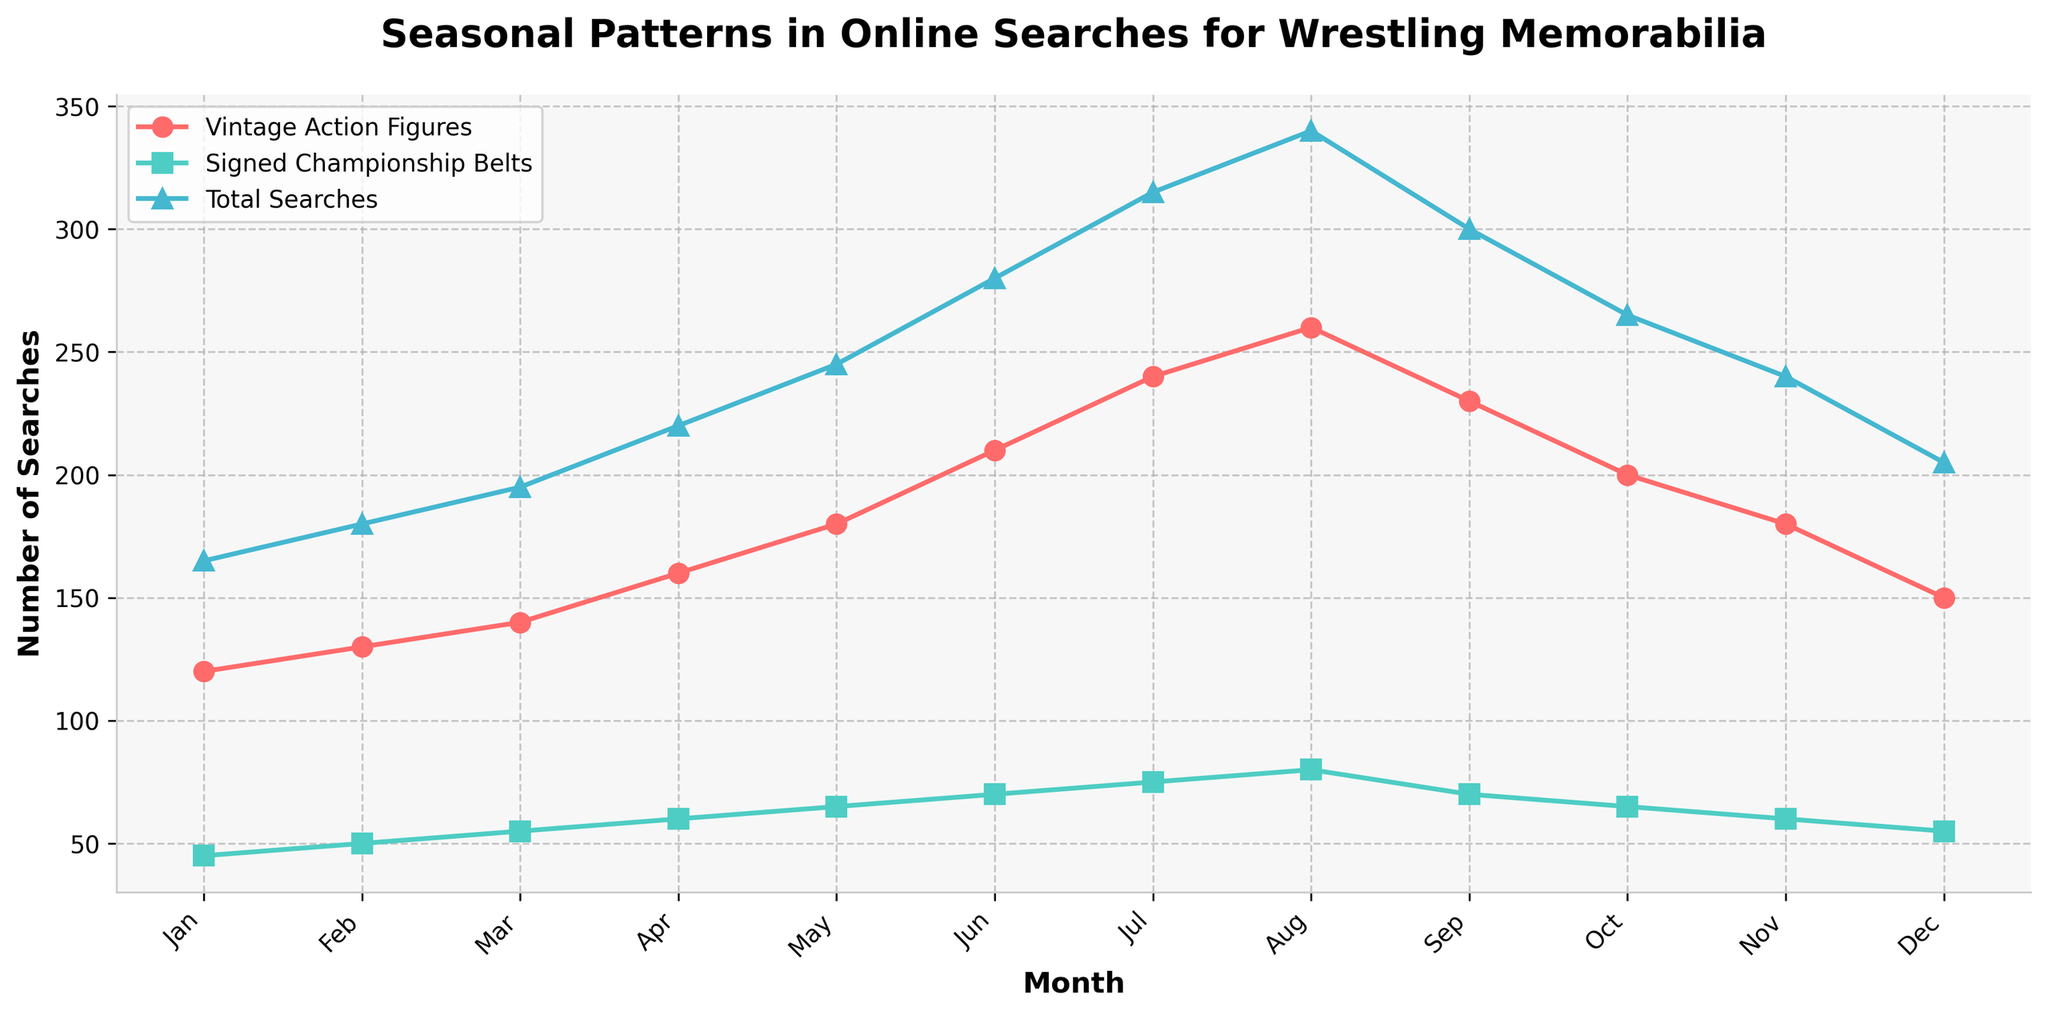What's the title of the figure? The title is typically placed at the top of the figure and can be read directly from the visual.
Answer: Seasonal Patterns in Online Searches for Wrestling Memorabilia How many data points are there in the figure? Each month from January to December represents one data point on the x-axis, so there are 12 data points.
Answer: 12 Which month had the highest number of total searches? By looking at the 'Total Searches' line, we can see that August has the highest peak.
Answer: August In which month did the searches for vintage action figures peak? By observing the 'Searches for Vintage Action Figures' line, we see a peak in August.
Answer: August What's the difference in the number of searches for signed championship belts between July and December? In July, there were 75 searches, and in December there were 55 searches. The difference is 75 - 55.
Answer: 20 What's the average number of total searches across all months? Sum the 'Total Searches' for each month and divide by the number of months: (165 + 180 + 195 + 220 + 245 + 280 + 315 + 340 + 300 + 265 + 240 + 205) / 12.
Answer: 245 Which month has fewer searches for signed championship belts: February or October? By comparing the values, February has 50 searches and October has 65 searches. February has fewer searches.
Answer: February Is there any month where the number of searches for vintage action figures is the same as the total searches? The 'Searches for Vintage Action Figures' line does not intersect with the 'Total Searches' line at any point, indicating there is no such month.
Answer: No By how much did searches for vintage action figures increase from January to August? In January, searches were 120, and in August, they were 260. The increase is 260 - 120.
Answer: 140 During which month do total searches decline the most compared to the previous month? The steepest decline in the 'Total Searches' line is between August and September, dropping from 340 to 300. The decline is 340 - 300.
Answer: September 